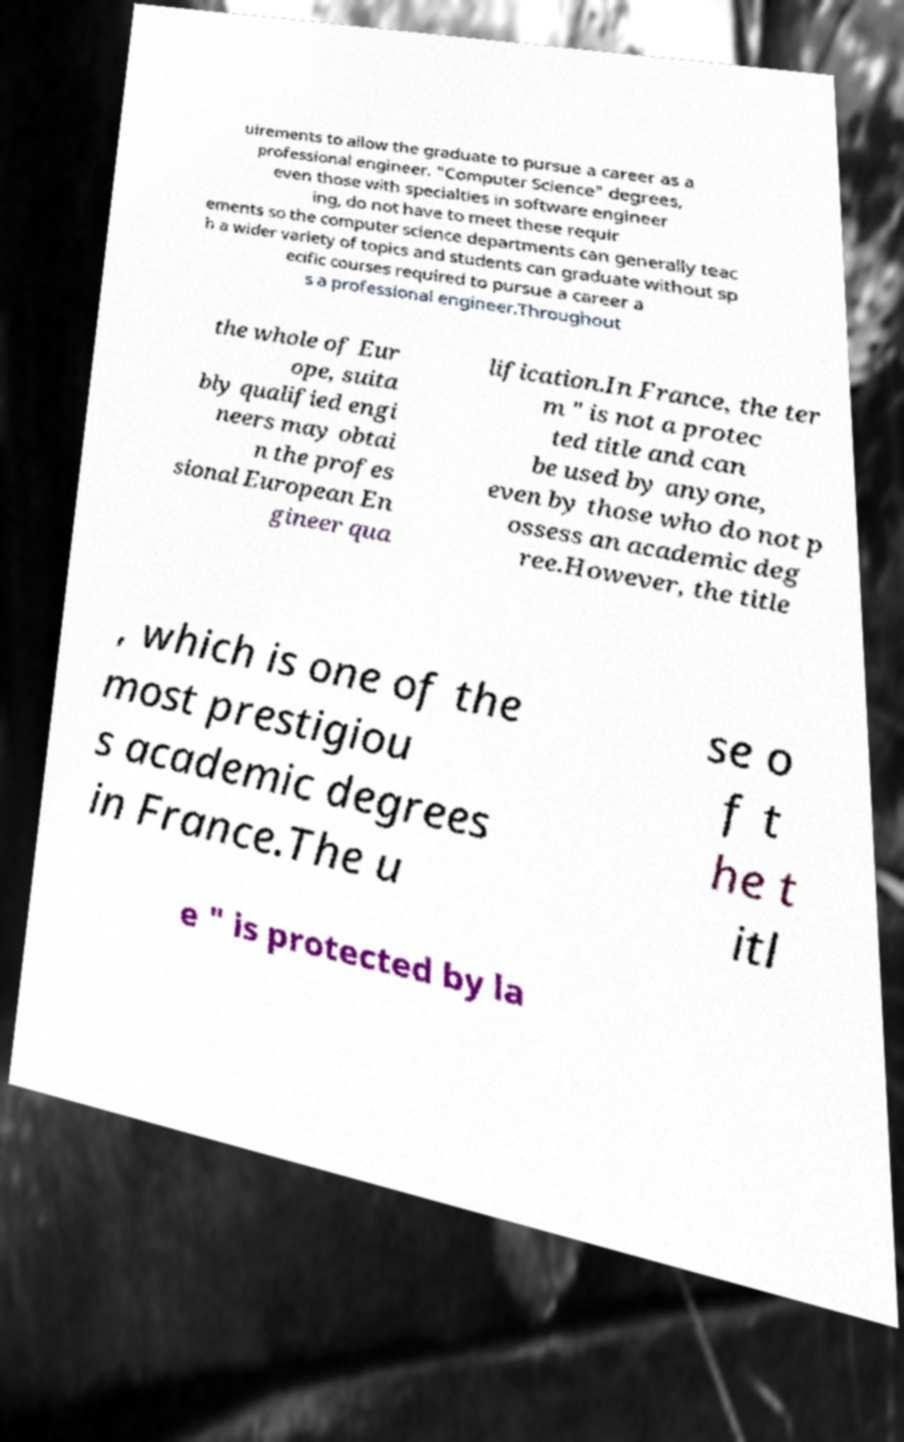Can you accurately transcribe the text from the provided image for me? uirements to allow the graduate to pursue a career as a professional engineer. "Computer Science" degrees, even those with specialties in software engineer ing, do not have to meet these requir ements so the computer science departments can generally teac h a wider variety of topics and students can graduate without sp ecific courses required to pursue a career a s a professional engineer.Throughout the whole of Eur ope, suita bly qualified engi neers may obtai n the profes sional European En gineer qua lification.In France, the ter m " is not a protec ted title and can be used by anyone, even by those who do not p ossess an academic deg ree.However, the title , which is one of the most prestigiou s academic degrees in France.The u se o f t he t itl e " is protected by la 